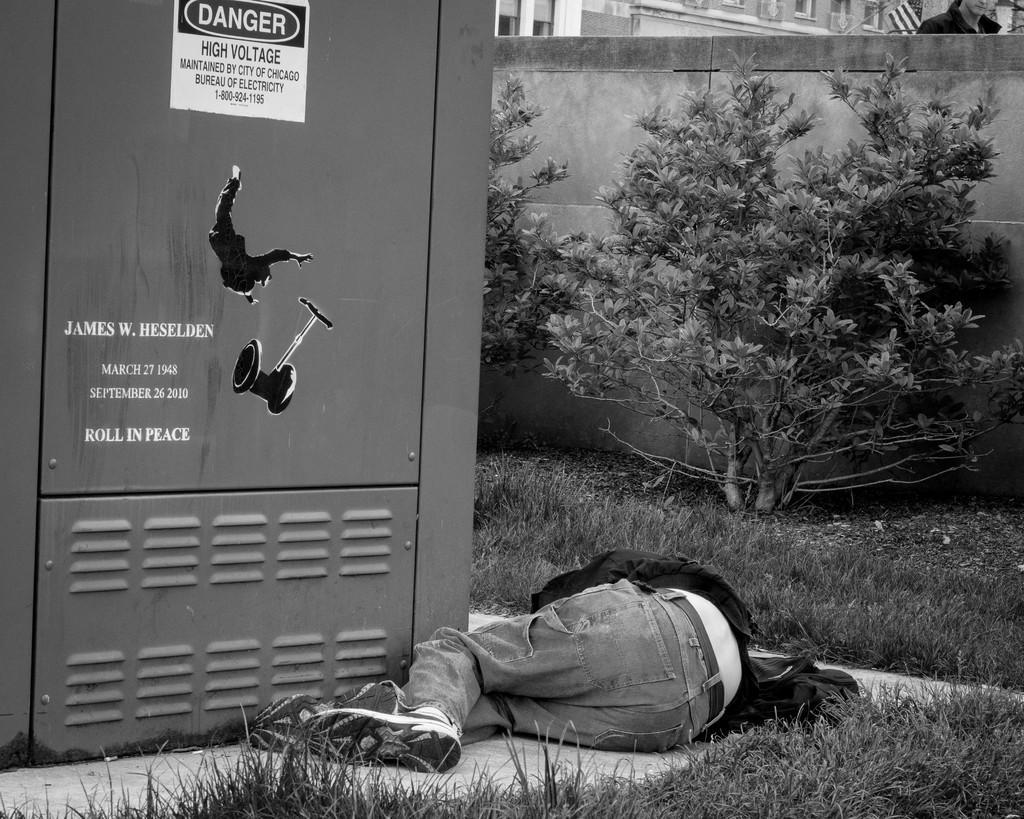Can you describe this image briefly? In this image, we can see a human is laying on the floor. Here we can see grass, and few plants. Background there is a wall, a person we can see here. On the left side of the image, we can see a box with some text and few stickers. 